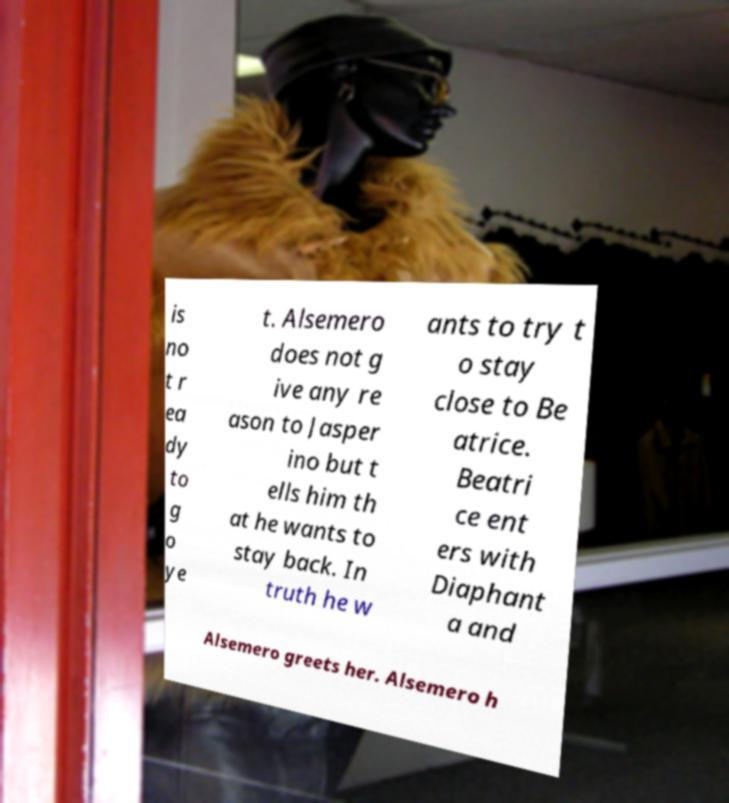Could you extract and type out the text from this image? is no t r ea dy to g o ye t. Alsemero does not g ive any re ason to Jasper ino but t ells him th at he wants to stay back. In truth he w ants to try t o stay close to Be atrice. Beatri ce ent ers with Diaphant a and Alsemero greets her. Alsemero h 